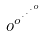<formula> <loc_0><loc_0><loc_500><loc_500>o ^ { o ^ { \cdot ^ { \cdot ^ { \cdot ^ { o } } } } }</formula> 